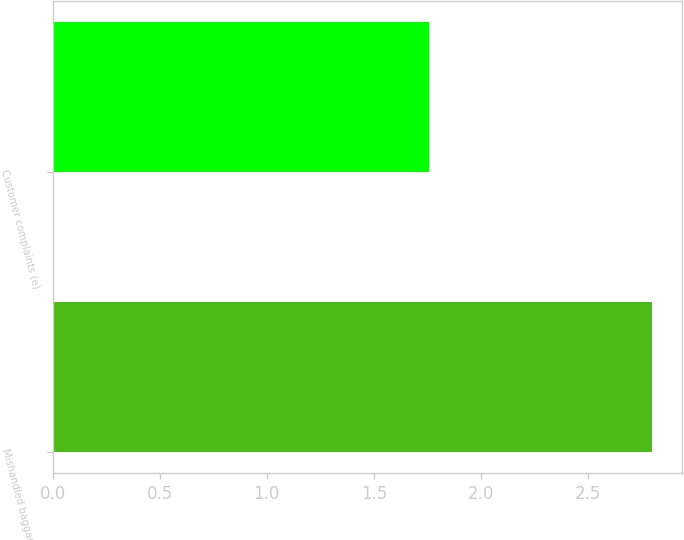Convert chart to OTSL. <chart><loc_0><loc_0><loc_500><loc_500><bar_chart><fcel>Mishandled baggage (d)<fcel>Customer complaints (e)<nl><fcel>2.8<fcel>1.76<nl></chart> 